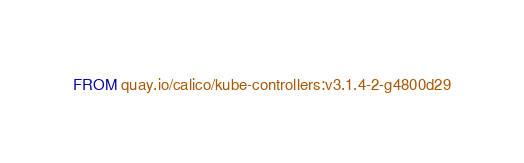<code> <loc_0><loc_0><loc_500><loc_500><_Dockerfile_>FROM quay.io/calico/kube-controllers:v3.1.4-2-g4800d29
</code> 